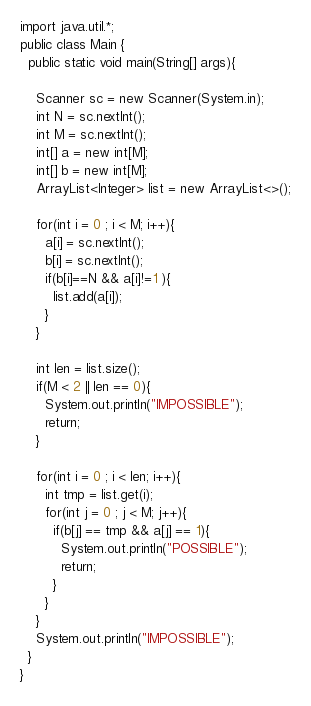<code> <loc_0><loc_0><loc_500><loc_500><_Java_>import java.util.*;
public class Main {
  public static void main(String[] args){
    
    Scanner sc = new Scanner(System.in);
    int N = sc.nextInt();
    int M = sc.nextInt();
    int[] a = new int[M];
    int[] b = new int[M];
    ArrayList<Integer> list = new ArrayList<>();
    
    for(int i = 0 ; i < M; i++){
      a[i] = sc.nextInt();
      b[i] = sc.nextInt();
      if(b[i]==N && a[i]!=1 ){
        list.add(a[i]);
      }
    }
    
    int len = list.size();
    if(M < 2 || len == 0){
      System.out.println("IMPOSSIBLE");
      return;
    }
    
    for(int i = 0 ; i < len; i++){
      int tmp = list.get(i);
      for(int j = 0 ; j < M; j++){
        if(b[j] == tmp && a[j] == 1){
          System.out.println("POSSIBLE");
          return; 
        }
      }
    }
    System.out.println("IMPOSSIBLE");
  }
}</code> 